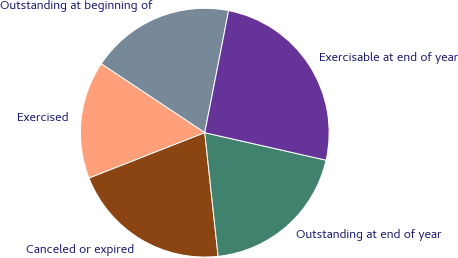Convert chart. <chart><loc_0><loc_0><loc_500><loc_500><pie_chart><fcel>Outstanding at beginning of<fcel>Exercised<fcel>Canceled or expired<fcel>Outstanding at end of year<fcel>Exercisable at end of year<nl><fcel>18.73%<fcel>15.29%<fcel>20.76%<fcel>19.74%<fcel>25.48%<nl></chart> 